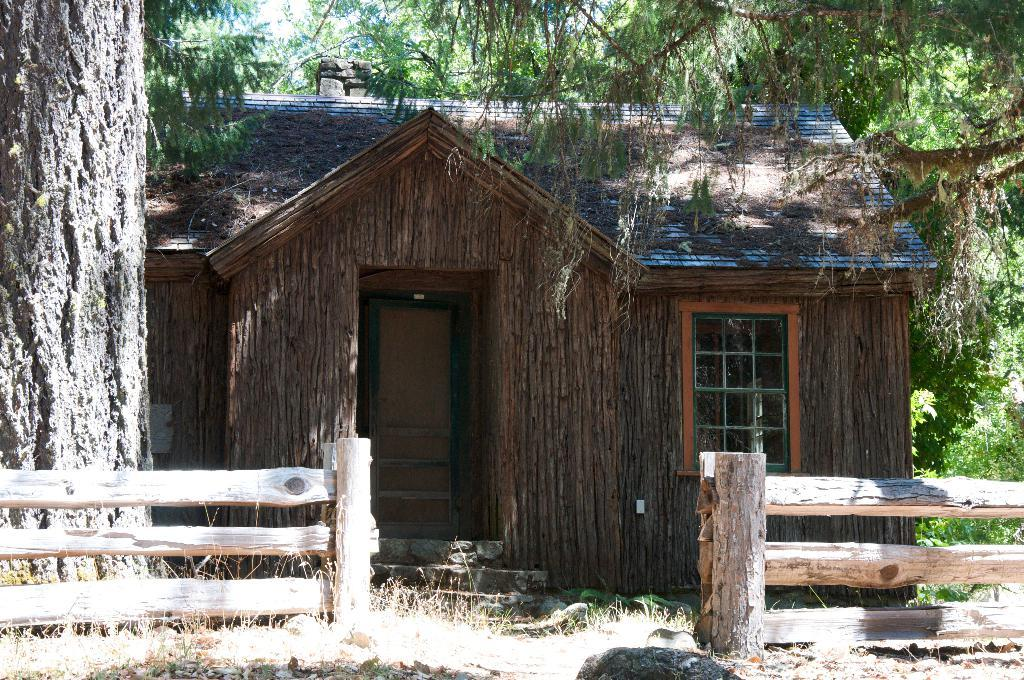What type of structure is present in the image? There is a shed in the image. What features does the shed have? The shed has a door and a window. What is in front of the shed? There is a wooden fence and a tree trunk in front of the shed, as well as some objects. What can be seen in the background of the image? There are trees visible in the background of the image. What type of print can be seen on the houses in the image? There are no houses present in the image; it only features a shed. How many times has the tree trunk been crushed in the image? There is no indication of any tree trunk being crushed in the image. 